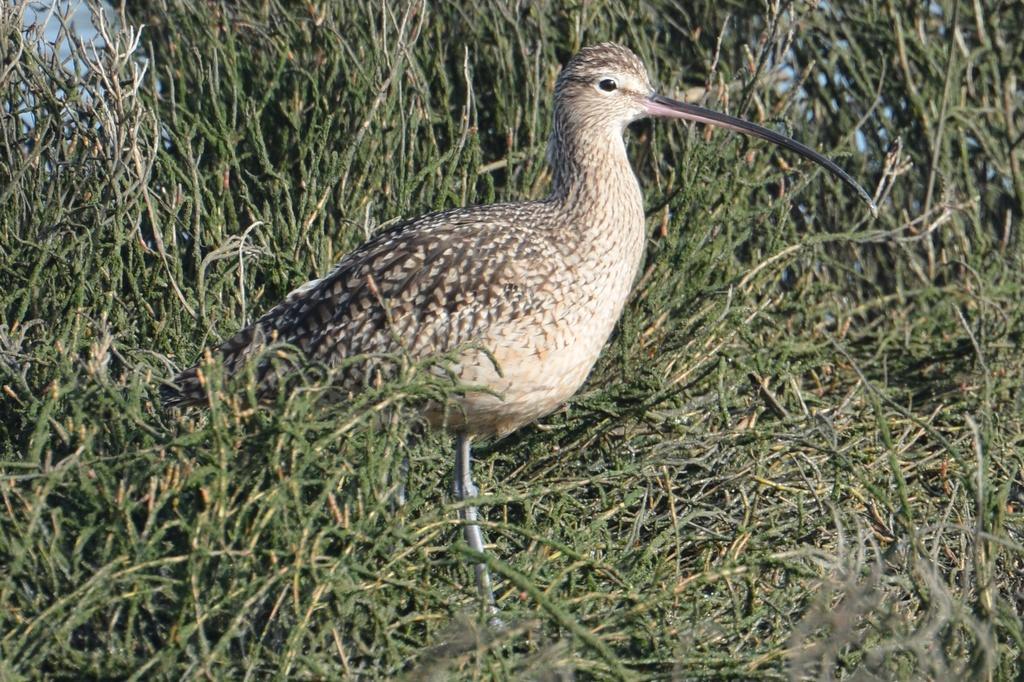Could you give a brief overview of what you see in this image? In this image I can see the bird in brown and black color. In the background I can see the green grass. 